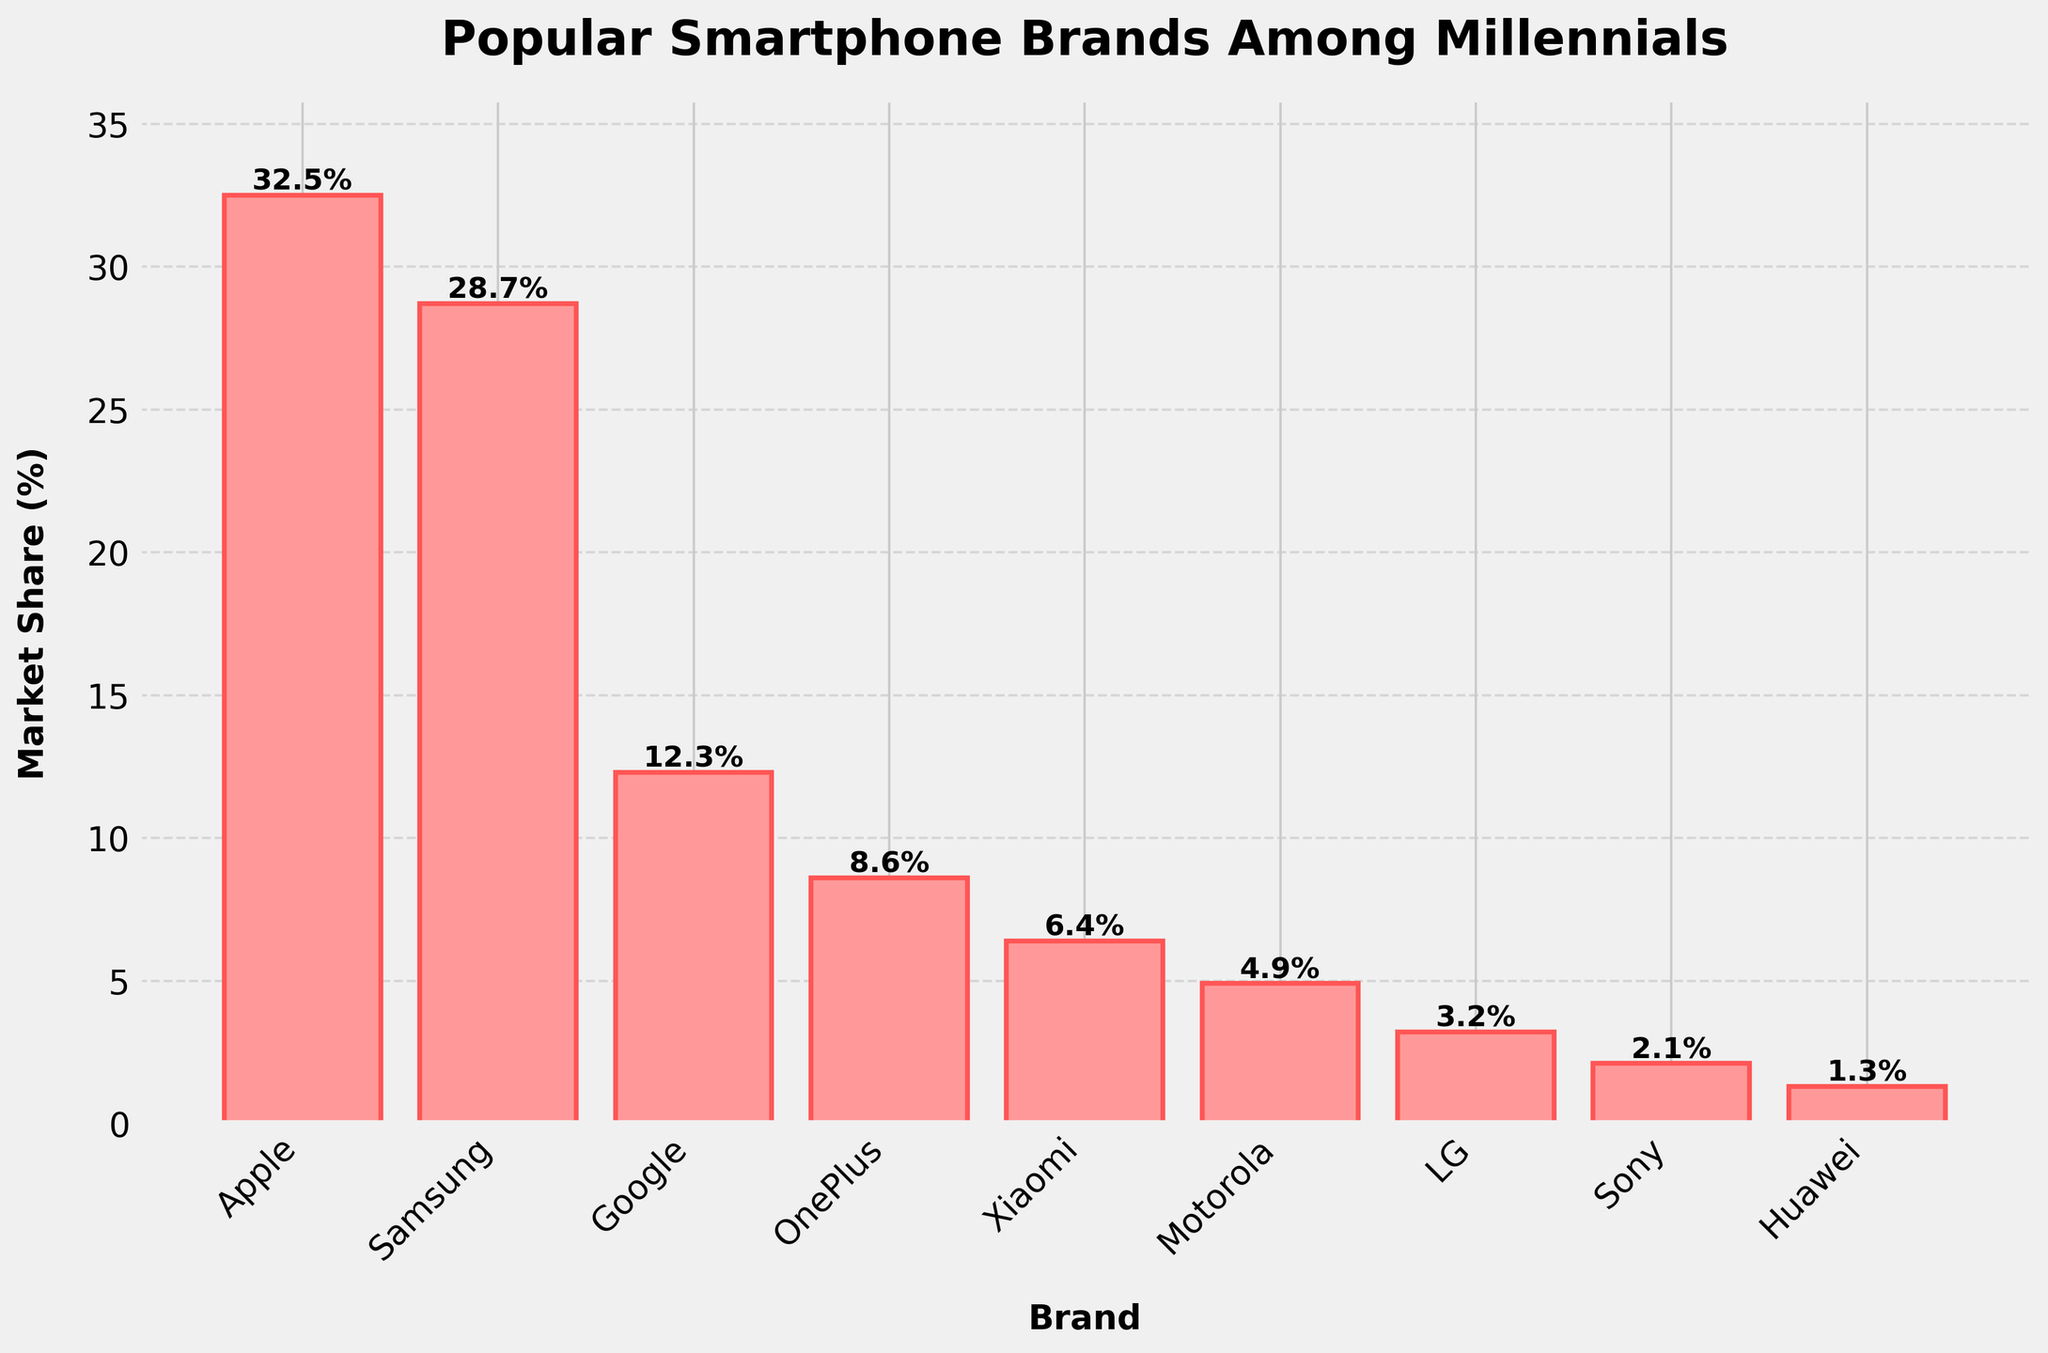Which brand has the highest market share? Look at the heights of the bars and the labels on the x-axis. The tallest bar corresponds to Apple.
Answer: Apple Which brand has the lowest market share? Look at the heights of the bars and the labels on the x-axis. The shortest bar corresponds to Huawei.
Answer: Huawei What is the difference in market share between Apple and Samsung? Find the heights of the bars for Apple and Samsung. Apple has 32.5% and Samsung has 28.7%. Subtract Samsung's market share from Apple's: 32.5% - 28.7% = 3.8%.
Answer: 3.8% What is the combined market share of Google, OnePlus, and Xiaomi? Find the heights of the bars for Google (12.3%), OnePlus (8.6%), and Xiaomi (6.4%). Add these values together: 12.3% + 8.6% + 6.4% = 27.3%.
Answer: 27.3% Which brand has a market share closest to 10%? Look at the heights of the bars and identify the one closest to 10%. The height of the bar for Google is 12.3%, which is the closest to 10%.
Answer: Google Which brands have a market share greater than 5%? Look at the heights of the bars and identify the ones that are above the 5% mark. The brands with market shares greater than 5% are Apple, Samsung, Google, OnePlus, and Xiaomi.
Answer: Apple, Samsung, Google, OnePlus, Xiaomi Are there more brands with a market share above or below 5%? Count the number of brands with market shares above and below 5%. There are 5 brands above 5% (Apple, Samsung, Google, OnePlus, Xiaomi) and 4 brands below 5% (Motorola, LG, Sony, Huawei). Therefore, there are more brands above 5%.
Answer: Above What is the average market share of brands with more than 5%? Identify the brands with more than 5% market share: Apple (32.5%), Samsung (28.7%), Google (12.3%), OnePlus (8.6%), and Xiaomi (6.4%). Sum these values: 32.5 + 28.7 + 12.3 + 8.6 + 6.4 = 88.5. There are 5 brands, so divide by 5: 88.5 / 5 = 17.7%.
Answer: 17.7% How much more market share does Apple have compared to LG, Sony, and Huawei combined? Find the heights of the bars for Apple (32.5%), LG (3.2%), Sony (2.1%), and Huawei (1.3%). Sum LG, Sony, and Huawei: 3.2% + 2.1% + 1.3% = 6.6%. Subtract this from Apple's market share: 32.5% - 6.6% = 25.9%.
Answer: 25.9% What is the difference between the market share of the top 3 brands and the bottom 3 brands? Identify the top 3 brands: Apple (32.5%), Samsung (28.7%), and Google (12.3%). Their combined share is 32.5 + 28.7 + 12.3 = 73.5%. Identify the bottom 3 brands: LG (3.2%), Sony (2.1%), and Huawei (1.3%). Their combined share is 3.2 + 2.1 + 1.3 = 6.6%. Subtract the combined share of the bottom 3 from the top 3: 73.5% - 6.6% = 66.9%.
Answer: 66.9% 